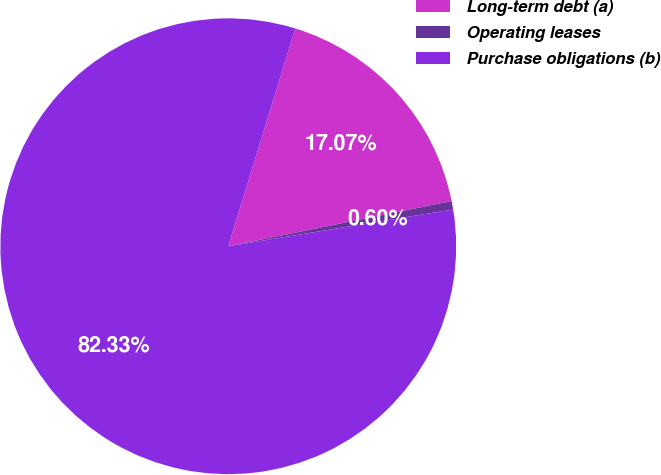Convert chart to OTSL. <chart><loc_0><loc_0><loc_500><loc_500><pie_chart><fcel>Long-term debt (a)<fcel>Operating leases<fcel>Purchase obligations (b)<nl><fcel>17.07%<fcel>0.6%<fcel>82.33%<nl></chart> 